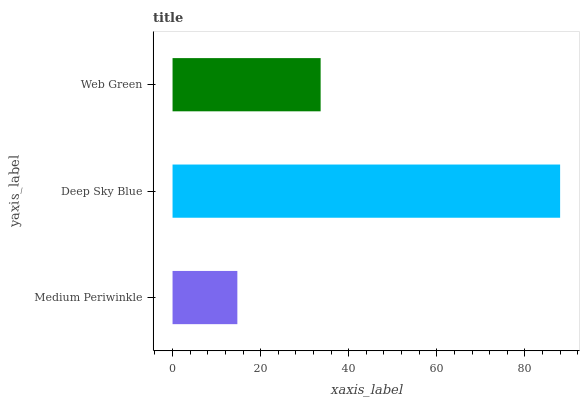Is Medium Periwinkle the minimum?
Answer yes or no. Yes. Is Deep Sky Blue the maximum?
Answer yes or no. Yes. Is Web Green the minimum?
Answer yes or no. No. Is Web Green the maximum?
Answer yes or no. No. Is Deep Sky Blue greater than Web Green?
Answer yes or no. Yes. Is Web Green less than Deep Sky Blue?
Answer yes or no. Yes. Is Web Green greater than Deep Sky Blue?
Answer yes or no. No. Is Deep Sky Blue less than Web Green?
Answer yes or no. No. Is Web Green the high median?
Answer yes or no. Yes. Is Web Green the low median?
Answer yes or no. Yes. Is Medium Periwinkle the high median?
Answer yes or no. No. Is Medium Periwinkle the low median?
Answer yes or no. No. 